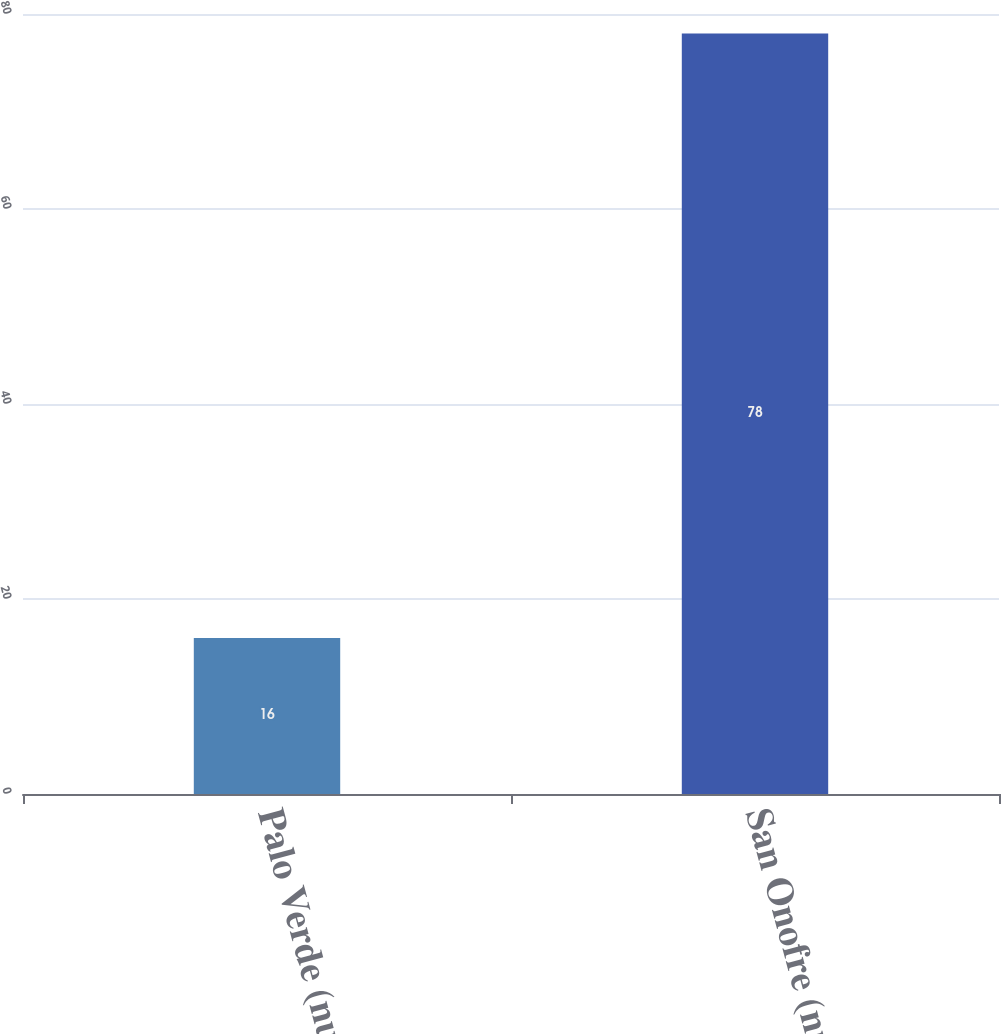Convert chart to OTSL. <chart><loc_0><loc_0><loc_500><loc_500><bar_chart><fcel>Palo Verde (nuclear)<fcel>San Onofre (nuclear)<nl><fcel>16<fcel>78<nl></chart> 